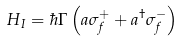Convert formula to latex. <formula><loc_0><loc_0><loc_500><loc_500>H _ { I } = \hbar { \Gamma } \left ( a \sigma ^ { + } _ { f } + a ^ { \dagger } \sigma ^ { - } _ { f } \right )</formula> 